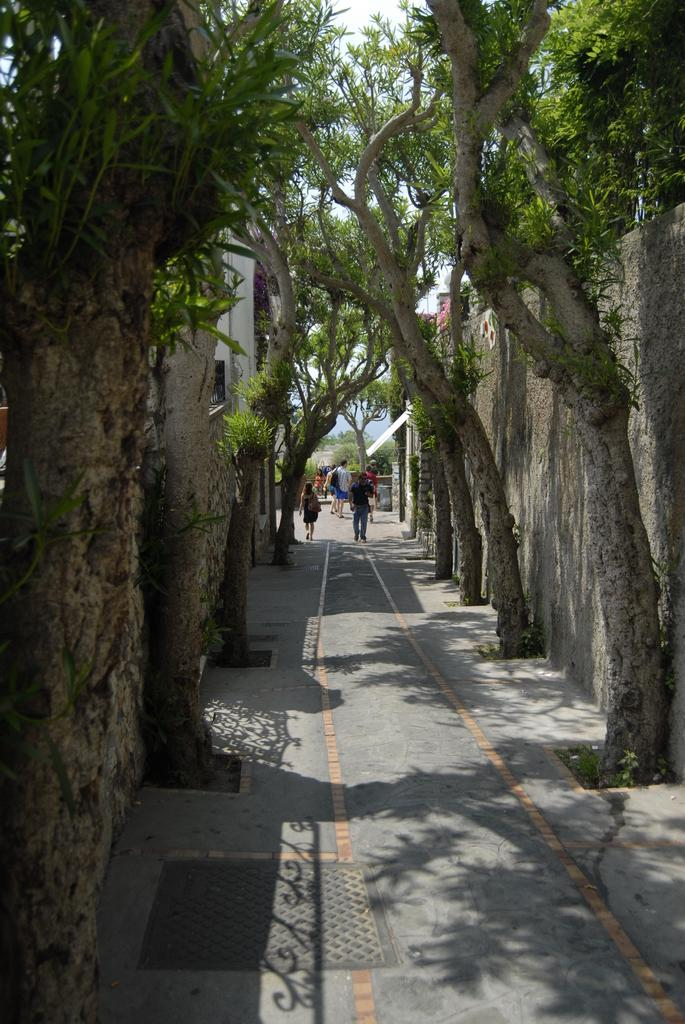What is happening in the center of the image? There are persons on the road in the center of the image. What can be seen on the right side of the image? There are buildings and a wall on the right side of the image, as well as trees. What can be seen on the left side of the image? There are buildings and a wall on the left side of the image, as well as trees. What is visible in the background of the image? There are trees and the sky visible in the background of the image. What type of lipstick is the person wearing in the image? There is no person wearing lipstick in the image. What kind of fruit is hanging from the trees in the image? There are no fruits visible on the trees in the image. 